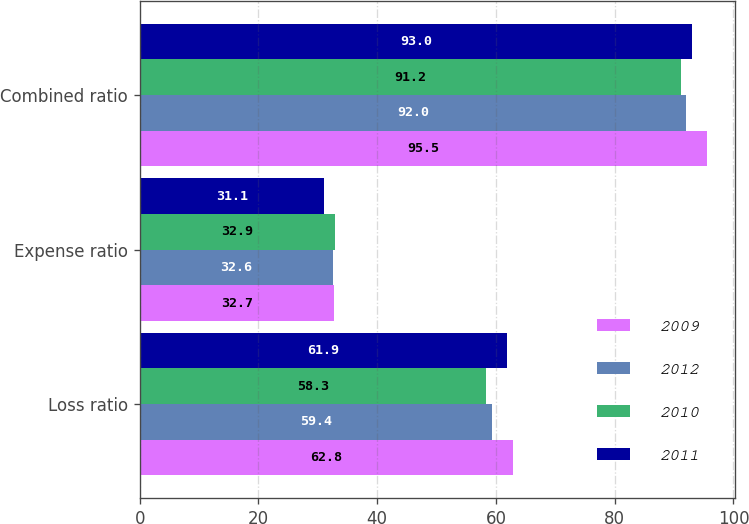Convert chart to OTSL. <chart><loc_0><loc_0><loc_500><loc_500><stacked_bar_chart><ecel><fcel>Loss ratio<fcel>Expense ratio<fcel>Combined ratio<nl><fcel>2009<fcel>62.8<fcel>32.7<fcel>95.5<nl><fcel>2012<fcel>59.4<fcel>32.6<fcel>92<nl><fcel>2010<fcel>58.3<fcel>32.9<fcel>91.2<nl><fcel>2011<fcel>61.9<fcel>31.1<fcel>93<nl></chart> 